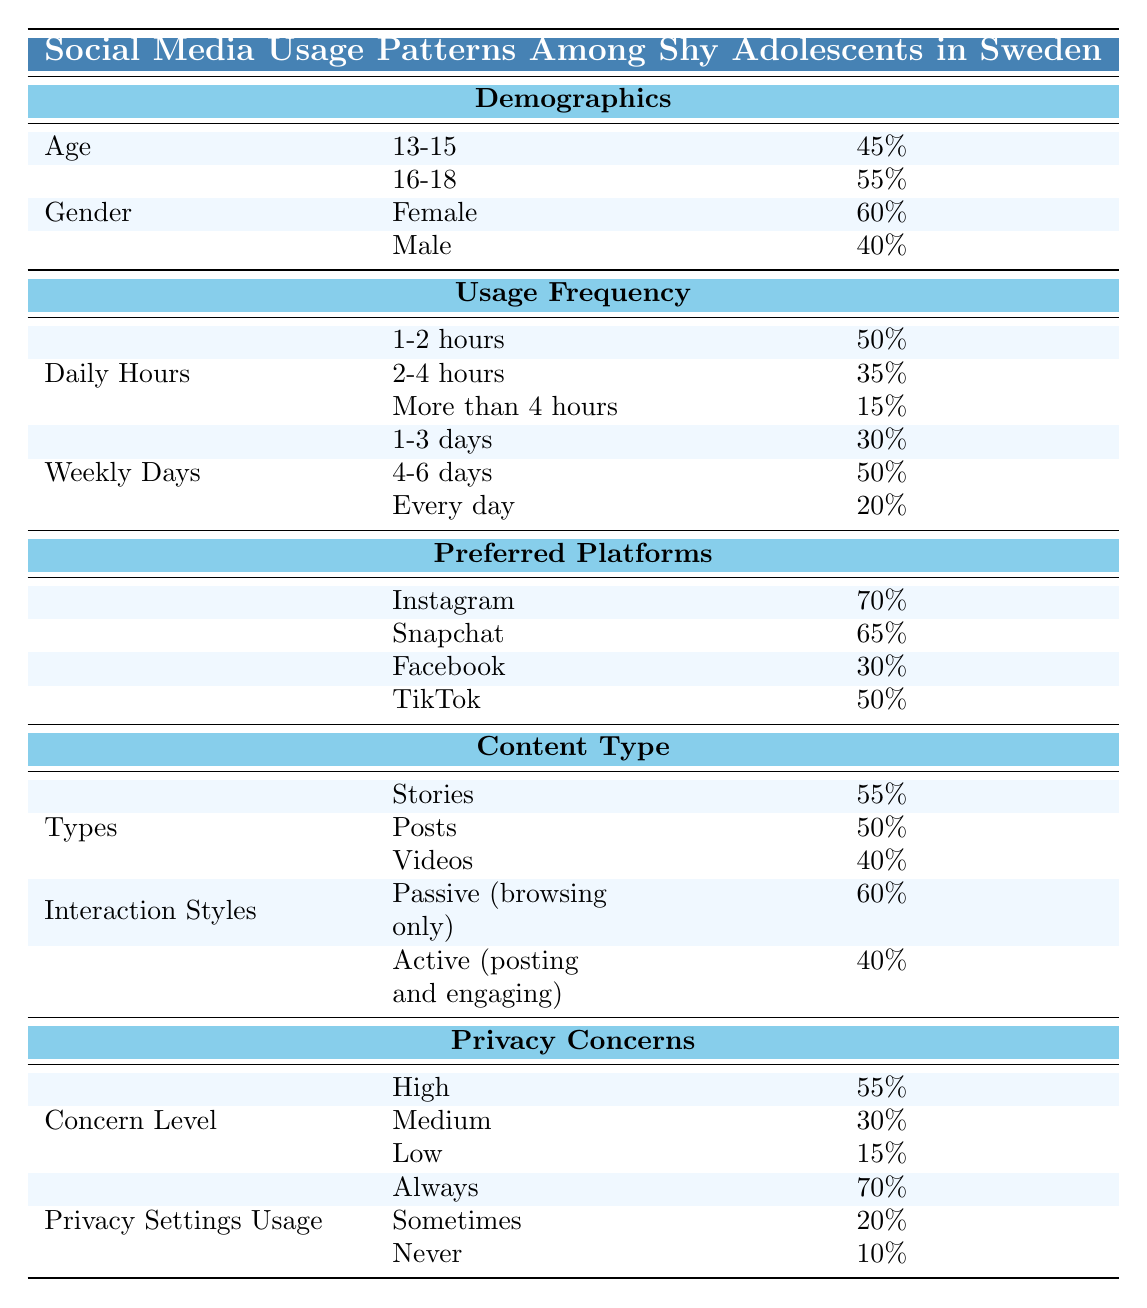What percentage of shy adolescents use Instagram as their preferred platform? The table shows the preferred platforms and their popularity. For Instagram, the percentage is given directly as 70%.
Answer: 70% What is the percentage of shy adolescents who use social media daily for 2 to 4 hours? In the "Usage Frequency" section under "Daily," the row for "2-4 hours" shows 35%.
Answer: 35% Is the concern level low for more than 10% of shy adolescents? Looking at the "Concern Level" in the "Privacy Concerns" section, the percentage for "Low" concern is 15%, which indeed is more than 10%.
Answer: Yes What is the combined percentage of shy adolescents who use social media for 1 to 3 days a week? From the "Weekly Days" section, "1-3 days" shows 30% and "4-6 days" shows 50%. Adding these gives 30% + 50% = 80%.
Answer: 80% What percentage of shy adolescents have high privacy concerns? In the "Concern Level" section, "High" is listed as 55%, so this is the answer.
Answer: 55% Which content type is most popular among shy adolescents, and what is its percentage? The "Content Type" section indicates "Stories" has the highest percentage, which is 55%.
Answer: Stories, 55% What percentage of shy adolescents are active users (posting and engaging) on social media? In the "Interaction Styles" subsection, the "Active (posting and engaging)" shows a percentage of 40%.
Answer: 40% If we consider all hours of daily social media usage, what is the percentage of adolescents who spend more than two hours daily? The total for "2-4 hours" is 35% and "More than 4 hours" is 15%. Adding them: 35% + 15% = 50%.
Answer: 50% What is the percentage of shy adolescents that use privacy settings always? In the "Privacy Settings Usage" section, "Always" shows a percentage of 70%.
Answer: 70% 